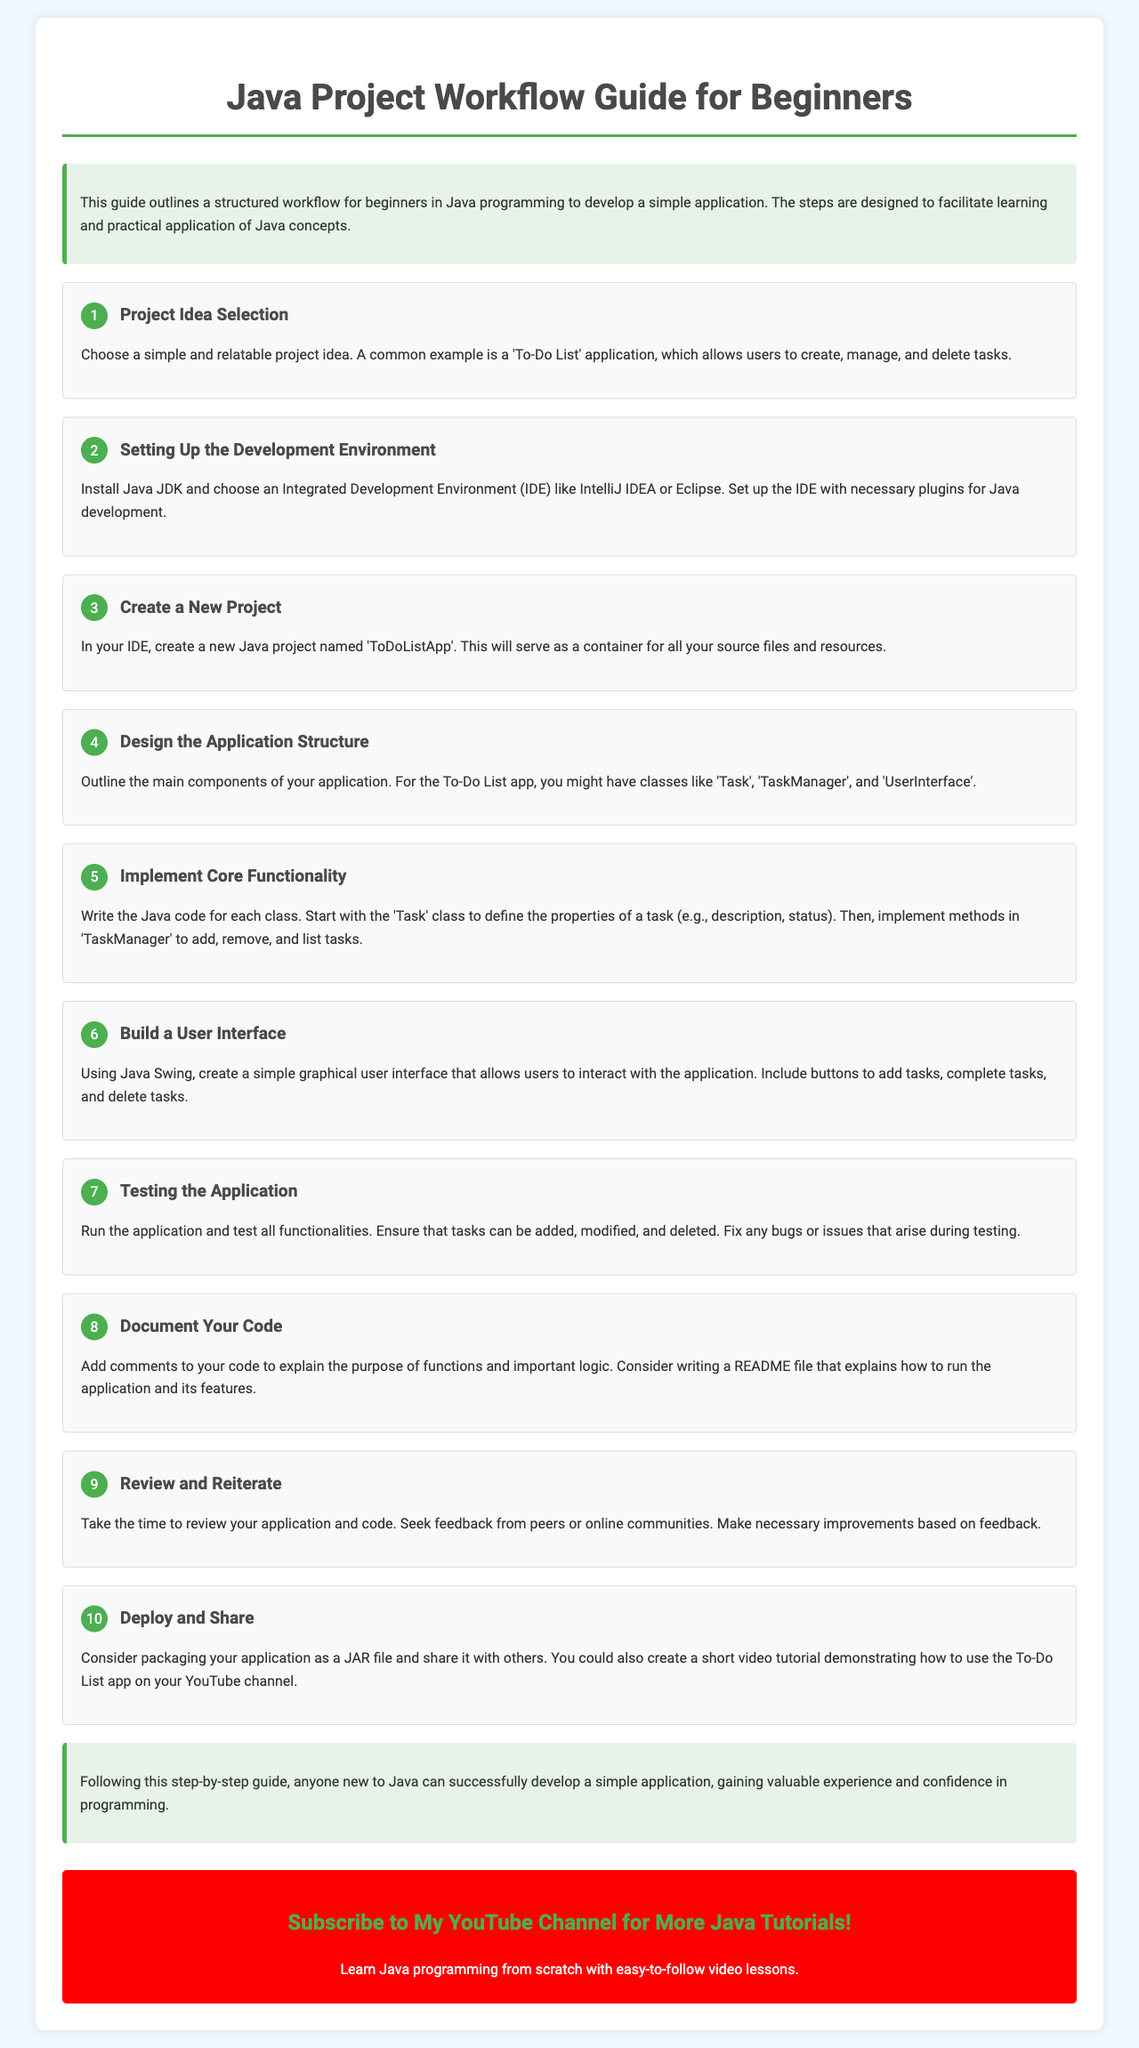What is the title of the guide? The title of the guide is indicated prominently at the top of the document.
Answer: Java Project Workflow Guide for Beginners How many steps are there in the workflow? The number of steps is mentioned before detailing the individual steps.
Answer: 10 What is the first step in the workflow? The first step is outlined as the initial action needed to begin the project.
Answer: Project Idea Selection What is an example project mentioned in the guide? An example project is specifically suggested to help beginners understand what to work on.
Answer: To-Do List application Which IDEs are suggested for setting up the development environment? The guide lists specific IDEs that can be used for Java development.
Answer: IntelliJ IDEA or Eclipse What does the user interface for the application use? The technology used for creating the application interface is mentioned in the relevant step.
Answer: Java Swing What should you do after testing the application? The workflow outlines recommended actions to improve the project after testing is completed.
Answer: Review and Reiterate What should be included in the README file? The guide suggests documentation practices that enhance understanding of the application.
Answer: How to run the application and its features What is the concluding action suggested by the guide? The last step of the workflow mentions how to share the finished application with others.
Answer: Deploy and Share 